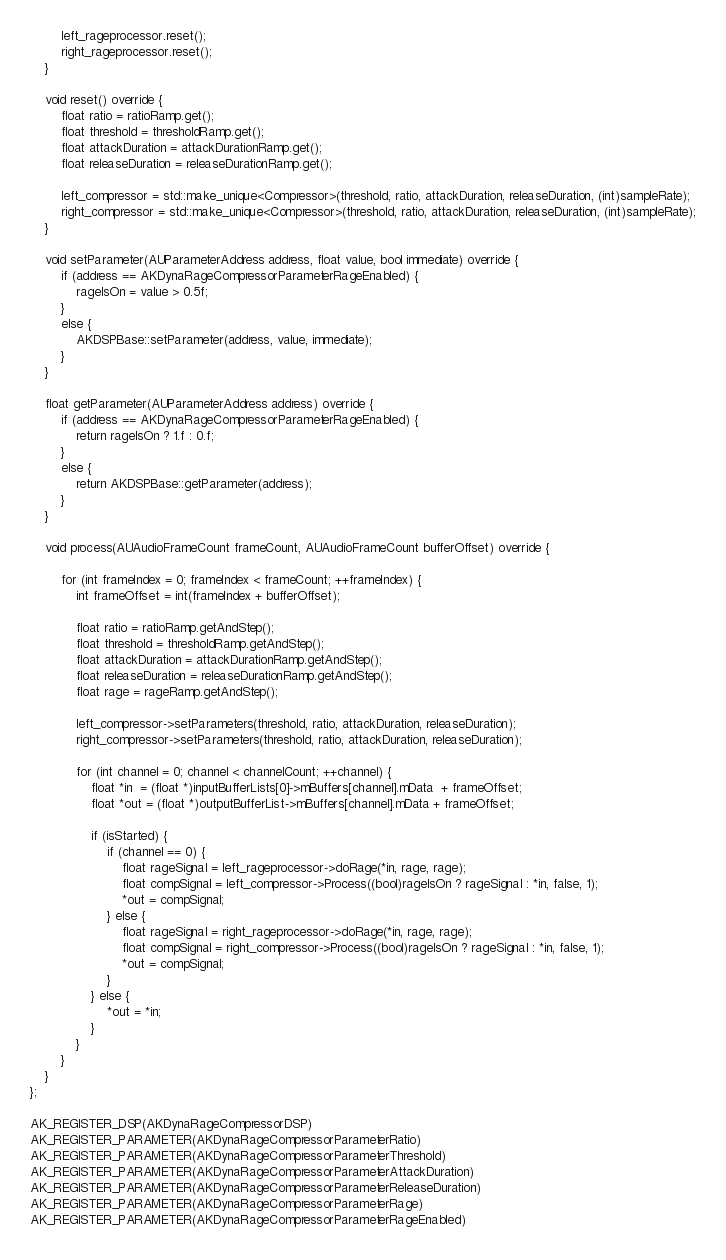<code> <loc_0><loc_0><loc_500><loc_500><_ObjectiveC_>        left_rageprocessor.reset();
        right_rageprocessor.reset();
    }

    void reset() override {
        float ratio = ratioRamp.get();
        float threshold = thresholdRamp.get();
        float attackDuration = attackDurationRamp.get();
        float releaseDuration = releaseDurationRamp.get();

        left_compressor = std::make_unique<Compressor>(threshold, ratio, attackDuration, releaseDuration, (int)sampleRate);
        right_compressor = std::make_unique<Compressor>(threshold, ratio, attackDuration, releaseDuration, (int)sampleRate);
    }

    void setParameter(AUParameterAddress address, float value, bool immediate) override {
        if (address == AKDynaRageCompressorParameterRageEnabled) {
            rageIsOn = value > 0.5f;
        }
        else {
            AKDSPBase::setParameter(address, value, immediate);
        }
    }

    float getParameter(AUParameterAddress address) override {
        if (address == AKDynaRageCompressorParameterRageEnabled) {
            return rageIsOn ? 1.f : 0.f;
        }
        else {
            return AKDSPBase::getParameter(address);
        }
    }

    void process(AUAudioFrameCount frameCount, AUAudioFrameCount bufferOffset) override {

        for (int frameIndex = 0; frameIndex < frameCount; ++frameIndex) {
            int frameOffset = int(frameIndex + bufferOffset);

            float ratio = ratioRamp.getAndStep();
            float threshold = thresholdRamp.getAndStep();
            float attackDuration = attackDurationRamp.getAndStep();
            float releaseDuration = releaseDurationRamp.getAndStep();
            float rage = rageRamp.getAndStep();

            left_compressor->setParameters(threshold, ratio, attackDuration, releaseDuration);
            right_compressor->setParameters(threshold, ratio, attackDuration, releaseDuration);

            for (int channel = 0; channel < channelCount; ++channel) {
                float *in  = (float *)inputBufferLists[0]->mBuffers[channel].mData  + frameOffset;
                float *out = (float *)outputBufferList->mBuffers[channel].mData + frameOffset;

                if (isStarted) {
                    if (channel == 0) {
                        float rageSignal = left_rageprocessor->doRage(*in, rage, rage);
                        float compSignal = left_compressor->Process((bool)rageIsOn ? rageSignal : *in, false, 1);
                        *out = compSignal;
                    } else {
                        float rageSignal = right_rageprocessor->doRage(*in, rage, rage);
                        float compSignal = right_compressor->Process((bool)rageIsOn ? rageSignal : *in, false, 1);
                        *out = compSignal;
                    }
                } else {
                    *out = *in;
                }
            }
        }
    }
};

AK_REGISTER_DSP(AKDynaRageCompressorDSP)
AK_REGISTER_PARAMETER(AKDynaRageCompressorParameterRatio)
AK_REGISTER_PARAMETER(AKDynaRageCompressorParameterThreshold)
AK_REGISTER_PARAMETER(AKDynaRageCompressorParameterAttackDuration)
AK_REGISTER_PARAMETER(AKDynaRageCompressorParameterReleaseDuration)
AK_REGISTER_PARAMETER(AKDynaRageCompressorParameterRage)
AK_REGISTER_PARAMETER(AKDynaRageCompressorParameterRageEnabled)
</code> 